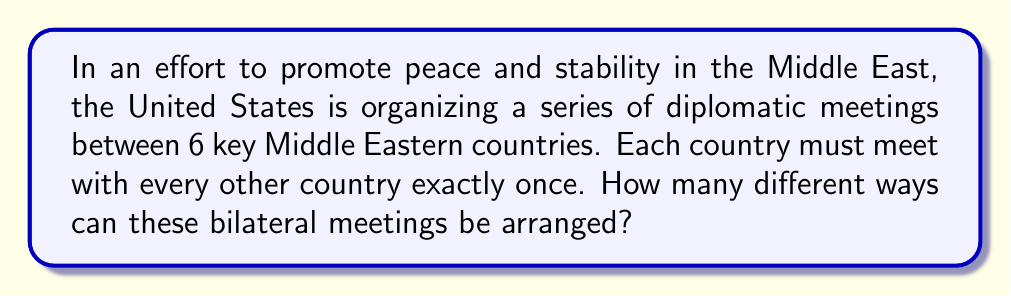Teach me how to tackle this problem. Let's approach this step-by-step:

1) First, we need to recognize that this is a combination problem. We're not arranging all countries in a line, but rather pairing them up for meetings.

2) The total number of bilateral meetings can be calculated using the combination formula:

   $$\binom{6}{2} = \frac{6!}{2!(6-2)!} = \frac{6 \cdot 5}{2} = 15$$

   So there will be 15 total meetings.

3) Now, we need to determine how many ways we can arrange these 15 meetings. This is a permutation of 15 items, which is simply 15!

4) Therefore, the total number of ways to arrange the meetings is:

   $$15! = 1,307,674,368,000$$

This large number reflects the complexity of diplomatic scheduling and the importance of careful planning in international relations.
Answer: $15! = 1,307,674,368,000$ ways 